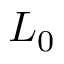<formula> <loc_0><loc_0><loc_500><loc_500>L _ { 0 }</formula> 